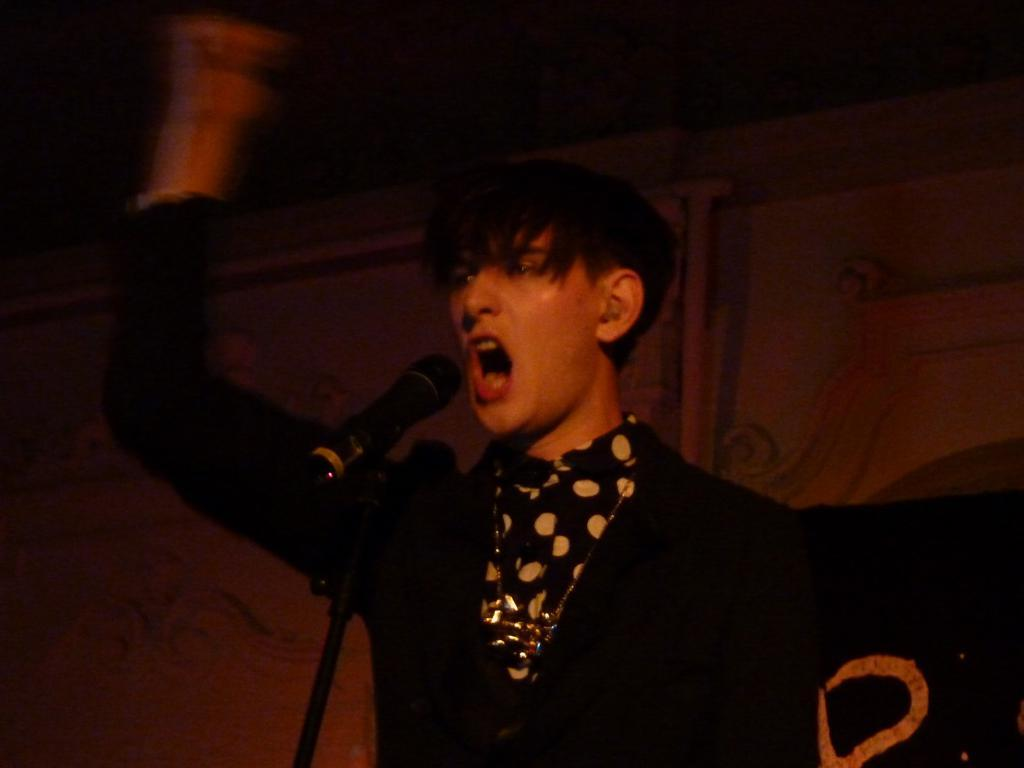Who is present in the image? There is a man in the image. What is the man wearing? The man is wearing a black dress. What is the man doing in the image? The man is standing in front of a microphone. What can be seen behind the man in the image? There is a wall visible in the background of the image. What type of animal is hiding behind the curtain in the image? There is no curtain or animal present in the image. 